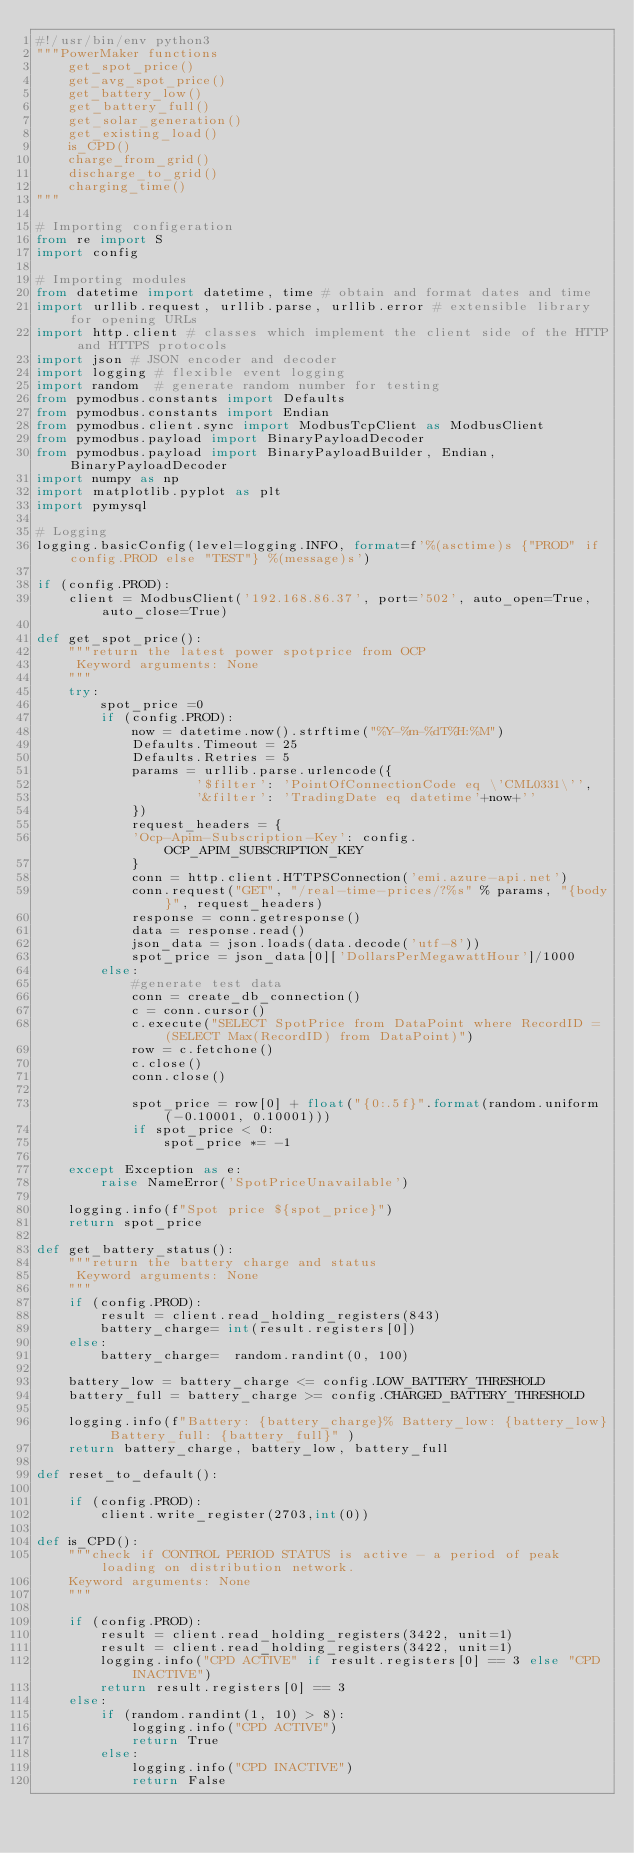Convert code to text. <code><loc_0><loc_0><loc_500><loc_500><_Python_>#!/usr/bin/env python3
"""PowerMaker functions
    get_spot_price()
    get_avg_spot_price()
    get_battery_low()
    get_battery_full()
    get_solar_generation()
    get_existing_load()       
    is_CPD()
    charge_from_grid()
    discharge_to_grid()
    charging_time()
"""

# Importing configeration
from re import S
import config

# Importing modules
from datetime import datetime, time # obtain and format dates and time
import urllib.request, urllib.parse, urllib.error # extensible library for opening URLs
import http.client # classes which implement the client side of the HTTP and HTTPS protocols
import json # JSON encoder and decoder
import logging # flexible event logging
import random  # generate random number for testing
from pymodbus.constants import Defaults
from pymodbus.constants import Endian
from pymodbus.client.sync import ModbusTcpClient as ModbusClient
from pymodbus.payload import BinaryPayloadDecoder
from pymodbus.payload import BinaryPayloadBuilder, Endian, BinaryPayloadDecoder
import numpy as np
import matplotlib.pyplot as plt
import pymysql

# Logging
logging.basicConfig(level=logging.INFO, format=f'%(asctime)s {"PROD" if config.PROD else "TEST"} %(message)s') 

if (config.PROD):
    client = ModbusClient('192.168.86.37', port='502', auto_open=True, auto_close=True)

def get_spot_price():
    """return the latest power spotprice from OCP
     Keyword arguments: None
    """
    try:
        spot_price =0
        if (config.PROD):
            now = datetime.now().strftime("%Y-%m-%dT%H:%M")
            Defaults.Timeout = 25
            Defaults.Retries = 5
            params = urllib.parse.urlencode({
                    '$filter': 'PointOfConnectionCode eq \'CML0331\'',
                    '&filter': 'TradingDate eq datetime'+now+''
            })
            request_headers = {
            'Ocp-Apim-Subscription-Key': config.OCP_APIM_SUBSCRIPTION_KEY
            }
            conn = http.client.HTTPSConnection('emi.azure-api.net')
            conn.request("GET", "/real-time-prices/?%s" % params, "{body}", request_headers)
            response = conn.getresponse()
            data = response.read()
            json_data = json.loads(data.decode('utf-8'))
            spot_price = json_data[0]['DollarsPerMegawattHour']/1000 
        else:
            #generate test data
            conn = create_db_connection()       
            c = conn.cursor()
            c.execute("SELECT SpotPrice from DataPoint where RecordID = (SELECT Max(RecordID) from DataPoint)")
            row = c.fetchone()
            c.close()
            conn.close()
    
            spot_price = row[0] + float("{0:.5f}".format(random.uniform(-0.10001, 0.10001)))
            if spot_price < 0:
                spot_price *= -1     

    except Exception as e:
        raise NameError('SpotPriceUnavailable')

    logging.info(f"Spot price ${spot_price}")
    return spot_price 
    
def get_battery_status():
    """return the battery charge and status
     Keyword arguments: None
    """
    if (config.PROD):  
        result = client.read_holding_registers(843)
        battery_charge= int(result.registers[0])
    else:
        battery_charge=  random.randint(0, 100)    
    
    battery_low = battery_charge <= config.LOW_BATTERY_THRESHOLD
    battery_full = battery_charge >= config.CHARGED_BATTERY_THRESHOLD

    logging.info(f"Battery: {battery_charge}% Battery_low: {battery_low} Battery_full: {battery_full}" )
    return battery_charge, battery_low, battery_full

def reset_to_default():

    if (config.PROD):
        client.write_register(2703,int(0))

def is_CPD():
    """check if CONTROL PERIOD STATUS is active - a period of peak loading on distribution network.
    Keyword arguments: None
    """

    if (config.PROD):
        result = client.read_holding_registers(3422, unit=1)
        result = client.read_holding_registers(3422, unit=1)
        logging.info("CPD ACTIVE" if result.registers[0] == 3 else "CPD INACTIVE")
        return result.registers[0] == 3
    else:
        if (random.randint(1, 10) > 8):
            logging.info("CPD ACTIVE")
            return True
        else:
            logging.info("CPD INACTIVE")
            return False
</code> 